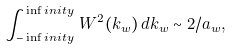<formula> <loc_0><loc_0><loc_500><loc_500>\int _ { - \inf i n i t y } ^ { \inf i n i t y } \, W ^ { 2 } ( k _ { w } ) \, d k _ { w } \sim 2 / a _ { w } ,</formula> 